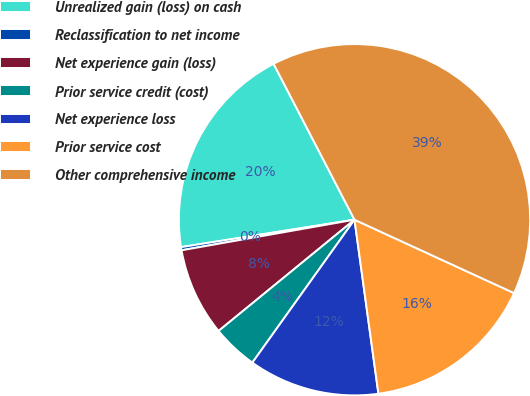Convert chart. <chart><loc_0><loc_0><loc_500><loc_500><pie_chart><fcel>Unrealized gain (loss) on cash<fcel>Reclassification to net income<fcel>Net experience gain (loss)<fcel>Prior service credit (cost)<fcel>Net experience loss<fcel>Prior service cost<fcel>Other comprehensive income<nl><fcel>19.88%<fcel>0.29%<fcel>8.13%<fcel>4.21%<fcel>12.05%<fcel>15.97%<fcel>39.48%<nl></chart> 